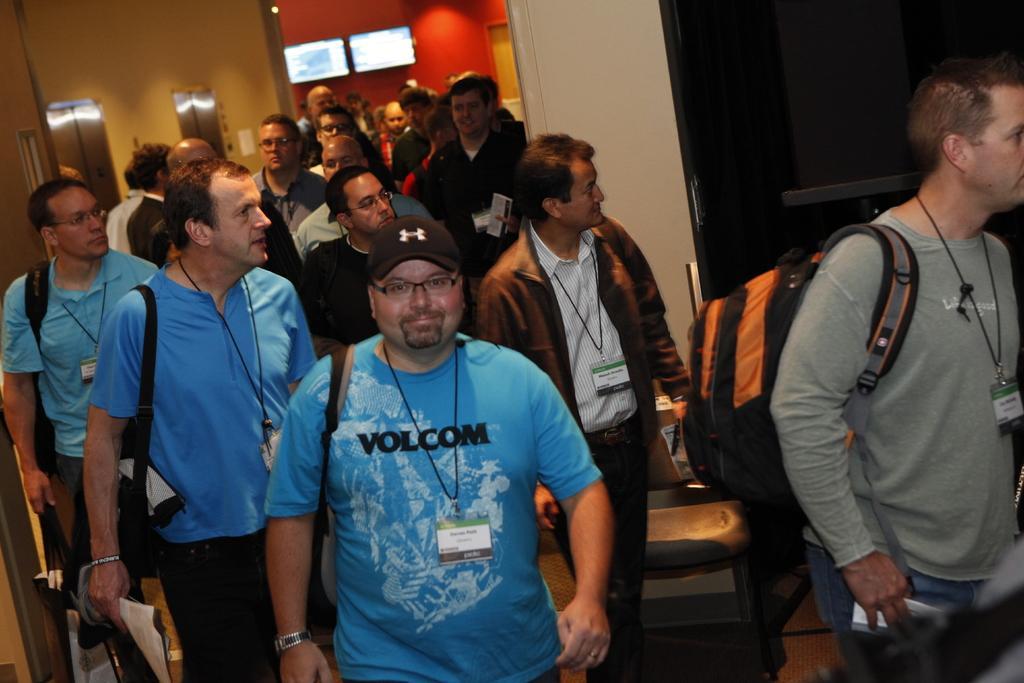Describe this image in one or two sentences. In this image I can see a crowd on the floor. In the background I can see a wall, doors and two monitors. This image is taken may be in a hall. 